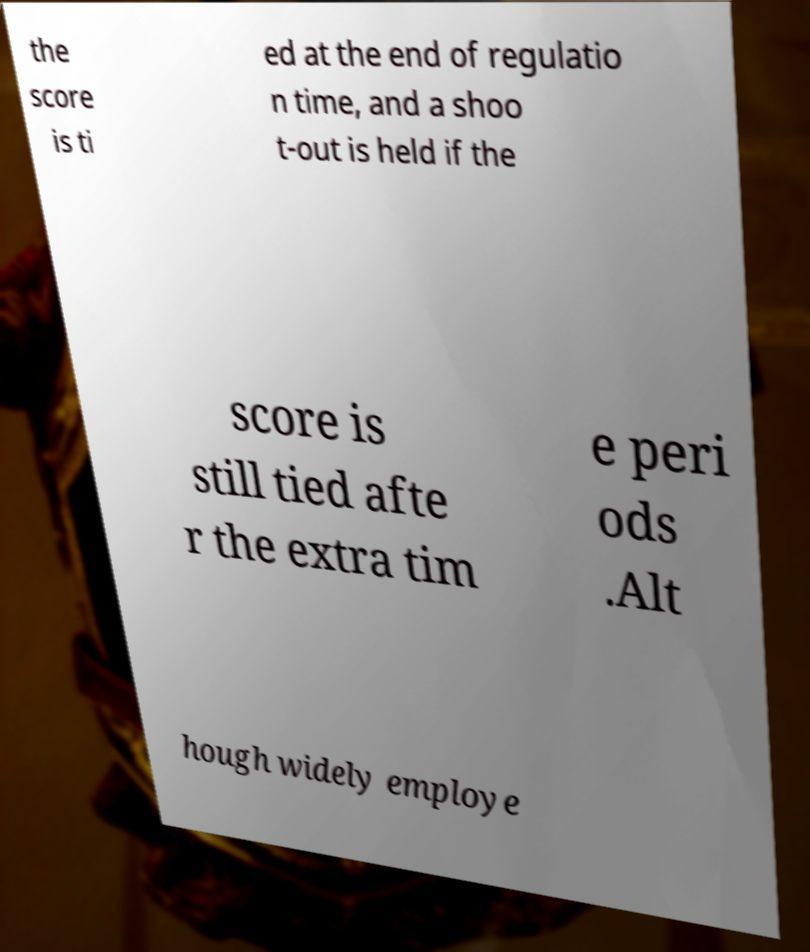Please identify and transcribe the text found in this image. the score is ti ed at the end of regulatio n time, and a shoo t-out is held if the score is still tied afte r the extra tim e peri ods .Alt hough widely employe 